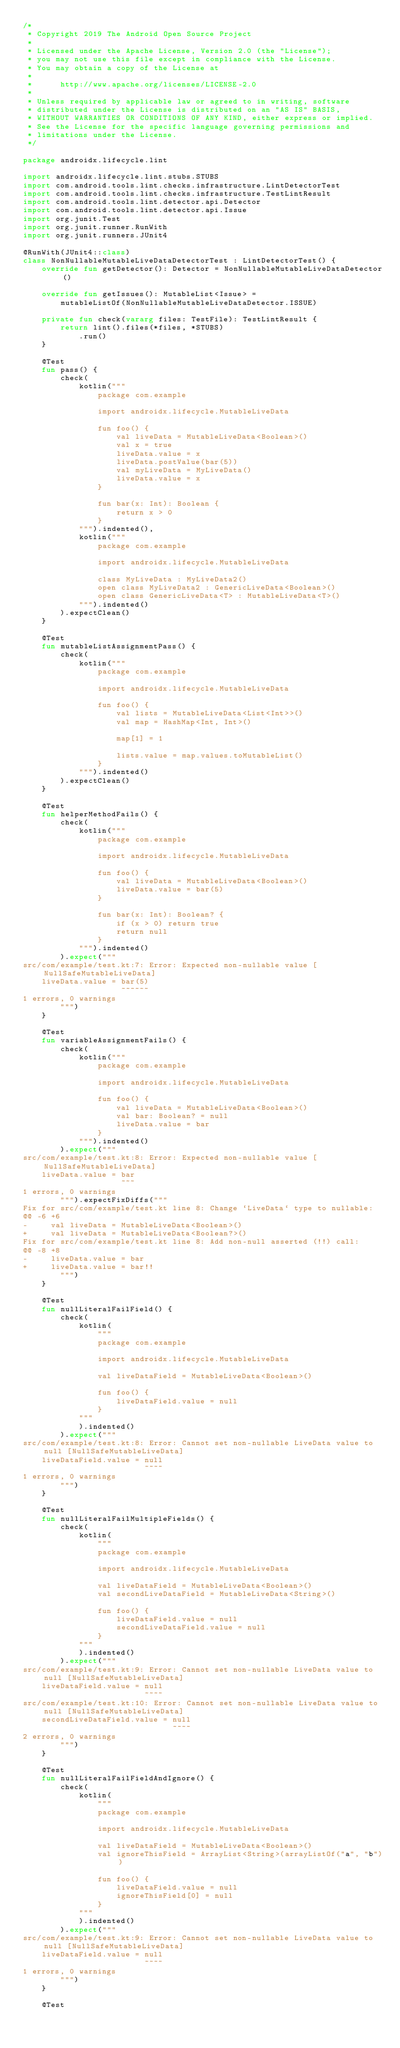<code> <loc_0><loc_0><loc_500><loc_500><_Kotlin_>/*
 * Copyright 2019 The Android Open Source Project
 *
 * Licensed under the Apache License, Version 2.0 (the "License");
 * you may not use this file except in compliance with the License.
 * You may obtain a copy of the License at
 *
 *      http://www.apache.org/licenses/LICENSE-2.0
 *
 * Unless required by applicable law or agreed to in writing, software
 * distributed under the License is distributed on an "AS IS" BASIS,
 * WITHOUT WARRANTIES OR CONDITIONS OF ANY KIND, either express or implied.
 * See the License for the specific language governing permissions and
 * limitations under the License.
 */

package androidx.lifecycle.lint

import androidx.lifecycle.lint.stubs.STUBS
import com.android.tools.lint.checks.infrastructure.LintDetectorTest
import com.android.tools.lint.checks.infrastructure.TestLintResult
import com.android.tools.lint.detector.api.Detector
import com.android.tools.lint.detector.api.Issue
import org.junit.Test
import org.junit.runner.RunWith
import org.junit.runners.JUnit4

@RunWith(JUnit4::class)
class NonNullableMutableLiveDataDetectorTest : LintDetectorTest() {
    override fun getDetector(): Detector = NonNullableMutableLiveDataDetector()

    override fun getIssues(): MutableList<Issue> =
        mutableListOf(NonNullableMutableLiveDataDetector.ISSUE)

    private fun check(vararg files: TestFile): TestLintResult {
        return lint().files(*files, *STUBS)
            .run()
    }

    @Test
    fun pass() {
        check(
            kotlin("""
                package com.example

                import androidx.lifecycle.MutableLiveData

                fun foo() {
                    val liveData = MutableLiveData<Boolean>()
                    val x = true
                    liveData.value = x
                    liveData.postValue(bar(5))
                    val myLiveData = MyLiveData()
                    liveData.value = x
                }

                fun bar(x: Int): Boolean {
                    return x > 0
                }
            """).indented(),
            kotlin("""
                package com.example

                import androidx.lifecycle.MutableLiveData

                class MyLiveData : MyLiveData2()
                open class MyLiveData2 : GenericLiveData<Boolean>()
                open class GenericLiveData<T> : MutableLiveData<T>()
            """).indented()
        ).expectClean()
    }

    @Test
    fun mutableListAssignmentPass() {
        check(
            kotlin("""
                package com.example

                import androidx.lifecycle.MutableLiveData

                fun foo() {
                    val lists = MutableLiveData<List<Int>>()
                    val map = HashMap<Int, Int>()

                    map[1] = 1

                    lists.value = map.values.toMutableList()
                }
            """).indented()
        ).expectClean()
    }

    @Test
    fun helperMethodFails() {
        check(
            kotlin("""
                package com.example

                import androidx.lifecycle.MutableLiveData

                fun foo() {
                    val liveData = MutableLiveData<Boolean>()
                    liveData.value = bar(5)
                }

                fun bar(x: Int): Boolean? {
                    if (x > 0) return true
                    return null
                }
            """).indented()
        ).expect("""
src/com/example/test.kt:7: Error: Expected non-nullable value [NullSafeMutableLiveData]
    liveData.value = bar(5)
                     ~~~~~~
1 errors, 0 warnings
        """)
    }

    @Test
    fun variableAssignmentFails() {
        check(
            kotlin("""
                package com.example

                import androidx.lifecycle.MutableLiveData

                fun foo() {
                    val liveData = MutableLiveData<Boolean>()
                    val bar: Boolean? = null
                    liveData.value = bar
                }
            """).indented()
        ).expect("""
src/com/example/test.kt:8: Error: Expected non-nullable value [NullSafeMutableLiveData]
    liveData.value = bar
                     ~~~
1 errors, 0 warnings
        """).expectFixDiffs("""
Fix for src/com/example/test.kt line 8: Change `LiveData` type to nullable:
@@ -6 +6
-     val liveData = MutableLiveData<Boolean>()
+     val liveData = MutableLiveData<Boolean?>()
Fix for src/com/example/test.kt line 8: Add non-null asserted (!!) call:
@@ -8 +8
-     liveData.value = bar
+     liveData.value = bar!!
        """)
    }

    @Test
    fun nullLiteralFailField() {
        check(
            kotlin(
                """
                package com.example

                import androidx.lifecycle.MutableLiveData

                val liveDataField = MutableLiveData<Boolean>()

                fun foo() {
                    liveDataField.value = null
                }
            """
            ).indented()
        ).expect("""
src/com/example/test.kt:8: Error: Cannot set non-nullable LiveData value to null [NullSafeMutableLiveData]
    liveDataField.value = null
                          ~~~~
1 errors, 0 warnings
        """)
    }

    @Test
    fun nullLiteralFailMultipleFields() {
        check(
            kotlin(
                """
                package com.example

                import androidx.lifecycle.MutableLiveData

                val liveDataField = MutableLiveData<Boolean>()
                val secondLiveDataField = MutableLiveData<String>()

                fun foo() {
                    liveDataField.value = null
                    secondLiveDataField.value = null
                }
            """
            ).indented()
        ).expect("""
src/com/example/test.kt:9: Error: Cannot set non-nullable LiveData value to null [NullSafeMutableLiveData]
    liveDataField.value = null
                          ~~~~
src/com/example/test.kt:10: Error: Cannot set non-nullable LiveData value to null [NullSafeMutableLiveData]
    secondLiveDataField.value = null
                                ~~~~
2 errors, 0 warnings
        """)
    }

    @Test
    fun nullLiteralFailFieldAndIgnore() {
        check(
            kotlin(
                """
                package com.example

                import androidx.lifecycle.MutableLiveData

                val liveDataField = MutableLiveData<Boolean>()
                val ignoreThisField = ArrayList<String>(arrayListOf("a", "b"))

                fun foo() {
                    liveDataField.value = null
                    ignoreThisField[0] = null
                }
            """
            ).indented()
        ).expect("""
src/com/example/test.kt:9: Error: Cannot set non-nullable LiveData value to null [NullSafeMutableLiveData]
    liveDataField.value = null
                          ~~~~
1 errors, 0 warnings
        """)
    }

    @Test</code> 